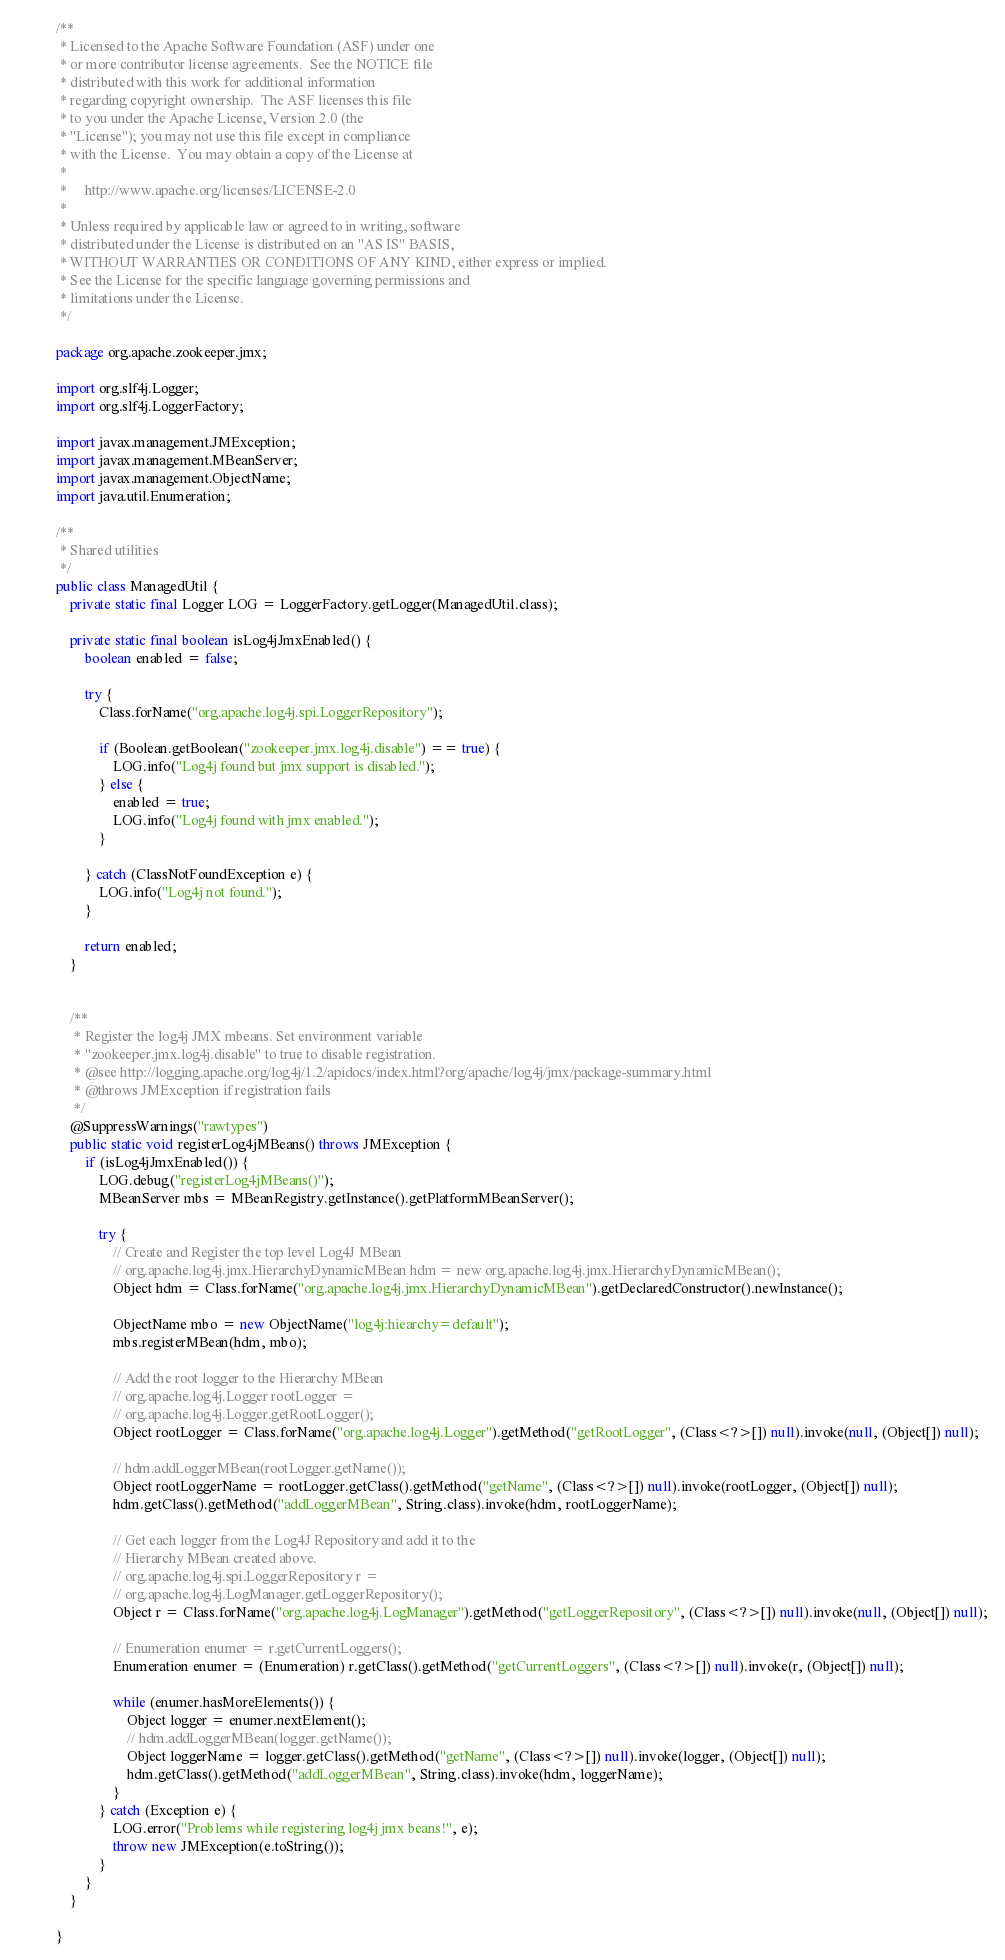Convert code to text. <code><loc_0><loc_0><loc_500><loc_500><_Java_>/**
 * Licensed to the Apache Software Foundation (ASF) under one
 * or more contributor license agreements.  See the NOTICE file
 * distributed with this work for additional information
 * regarding copyright ownership.  The ASF licenses this file
 * to you under the Apache License, Version 2.0 (the
 * "License"); you may not use this file except in compliance
 * with the License.  You may obtain a copy of the License at
 *
 *     http://www.apache.org/licenses/LICENSE-2.0
 *
 * Unless required by applicable law or agreed to in writing, software
 * distributed under the License is distributed on an "AS IS" BASIS,
 * WITHOUT WARRANTIES OR CONDITIONS OF ANY KIND, either express or implied.
 * See the License for the specific language governing permissions and
 * limitations under the License.
 */

package org.apache.zookeeper.jmx;

import org.slf4j.Logger;
import org.slf4j.LoggerFactory;

import javax.management.JMException;
import javax.management.MBeanServer;
import javax.management.ObjectName;
import java.util.Enumeration;

/**
 * Shared utilities
 */
public class ManagedUtil {
    private static final Logger LOG = LoggerFactory.getLogger(ManagedUtil.class);

    private static final boolean isLog4jJmxEnabled() {
        boolean enabled = false;

        try {
            Class.forName("org.apache.log4j.spi.LoggerRepository");

            if (Boolean.getBoolean("zookeeper.jmx.log4j.disable") == true) {
                LOG.info("Log4j found but jmx support is disabled.");
            } else {
                enabled = true;
                LOG.info("Log4j found with jmx enabled.");
            }

        } catch (ClassNotFoundException e) {
            LOG.info("Log4j not found.");
        }

        return enabled;
    }


    /**
     * Register the log4j JMX mbeans. Set environment variable
     * "zookeeper.jmx.log4j.disable" to true to disable registration.
     * @see http://logging.apache.org/log4j/1.2/apidocs/index.html?org/apache/log4j/jmx/package-summary.html
     * @throws JMException if registration fails
     */
    @SuppressWarnings("rawtypes")
    public static void registerLog4jMBeans() throws JMException {
        if (isLog4jJmxEnabled()) {
            LOG.debug("registerLog4jMBeans()");
            MBeanServer mbs = MBeanRegistry.getInstance().getPlatformMBeanServer();

            try {
                // Create and Register the top level Log4J MBean
                // org.apache.log4j.jmx.HierarchyDynamicMBean hdm = new org.apache.log4j.jmx.HierarchyDynamicMBean();
                Object hdm = Class.forName("org.apache.log4j.jmx.HierarchyDynamicMBean").getDeclaredConstructor().newInstance();

                ObjectName mbo = new ObjectName("log4j:hiearchy=default");
                mbs.registerMBean(hdm, mbo);

                // Add the root logger to the Hierarchy MBean
                // org.apache.log4j.Logger rootLogger =
                // org.apache.log4j.Logger.getRootLogger();
                Object rootLogger = Class.forName("org.apache.log4j.Logger").getMethod("getRootLogger", (Class<?>[]) null).invoke(null, (Object[]) null);

                // hdm.addLoggerMBean(rootLogger.getName());
                Object rootLoggerName = rootLogger.getClass().getMethod("getName", (Class<?>[]) null).invoke(rootLogger, (Object[]) null);
                hdm.getClass().getMethod("addLoggerMBean", String.class).invoke(hdm, rootLoggerName);

                // Get each logger from the Log4J Repository and add it to the
                // Hierarchy MBean created above.
                // org.apache.log4j.spi.LoggerRepository r =
                // org.apache.log4j.LogManager.getLoggerRepository();
                Object r = Class.forName("org.apache.log4j.LogManager").getMethod("getLoggerRepository", (Class<?>[]) null).invoke(null, (Object[]) null);

                // Enumeration enumer = r.getCurrentLoggers();
                Enumeration enumer = (Enumeration) r.getClass().getMethod("getCurrentLoggers", (Class<?>[]) null).invoke(r, (Object[]) null);

                while (enumer.hasMoreElements()) {
                    Object logger = enumer.nextElement();
                    // hdm.addLoggerMBean(logger.getName());
                    Object loggerName = logger.getClass().getMethod("getName", (Class<?>[]) null).invoke(logger, (Object[]) null);
                    hdm.getClass().getMethod("addLoggerMBean", String.class).invoke(hdm, loggerName);
                }
            } catch (Exception e) {
                LOG.error("Problems while registering log4j jmx beans!", e);
                throw new JMException(e.toString());
            }
        }
    }

}
</code> 